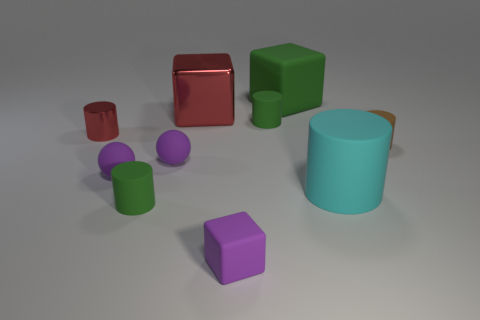Subtract all purple spheres. How many were subtracted if there are1purple spheres left? 1 Subtract all tiny purple blocks. How many blocks are left? 2 Subtract all spheres. How many objects are left? 8 Subtract 3 cubes. How many cubes are left? 0 Subtract all brown cylinders. Subtract all blue blocks. How many cylinders are left? 4 Subtract all green cubes. How many red cylinders are left? 1 Subtract all metal objects. Subtract all small metallic objects. How many objects are left? 7 Add 9 large red cubes. How many large red cubes are left? 10 Add 3 blue rubber cubes. How many blue rubber cubes exist? 3 Subtract all green cubes. How many cubes are left? 2 